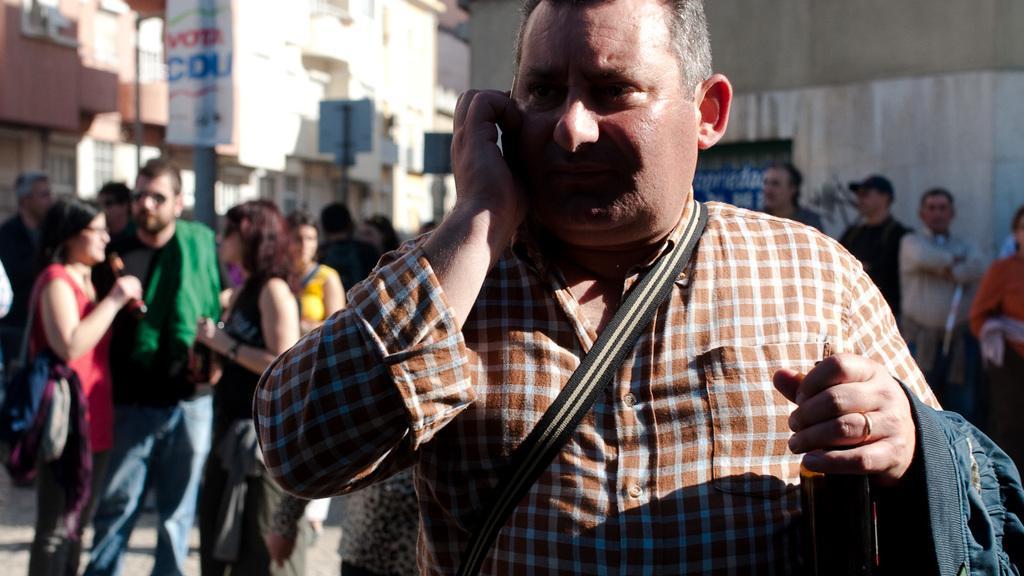In one or two sentences, can you explain what this image depicts? In this picture we can see a man and in the background we can see a group of people, buildings and some objects. 